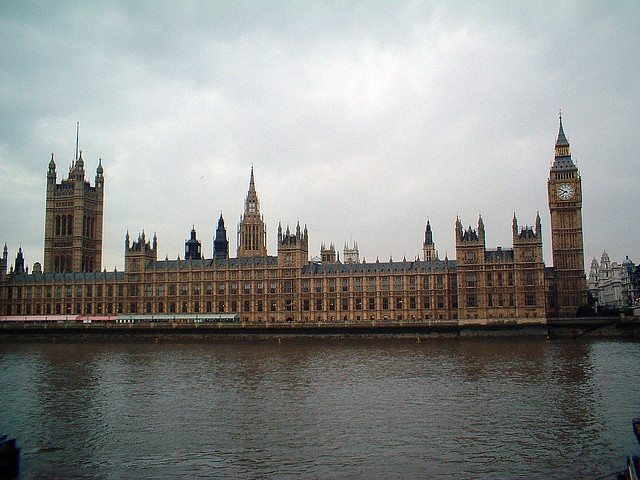Describe the objects in this image and their specific colors. I can see a clock in darkgray, gray, and lightgray tones in this image. 